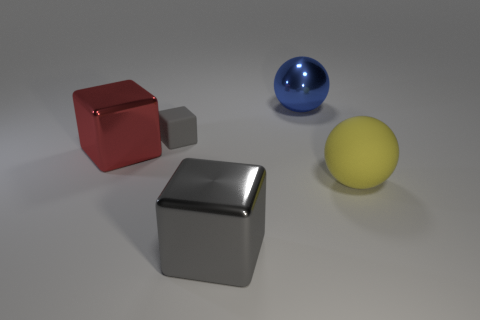Subtract all gray metallic blocks. How many blocks are left? 2 Subtract all gray balls. How many gray cubes are left? 2 Subtract 1 cubes. How many cubes are left? 2 Add 5 tiny gray rubber cubes. How many objects exist? 10 Subtract all balls. How many objects are left? 3 Subtract all cyan cubes. Subtract all red spheres. How many cubes are left? 3 Add 5 blue spheres. How many blue spheres exist? 6 Subtract 0 brown cubes. How many objects are left? 5 Subtract all large red metallic blocks. Subtract all blue objects. How many objects are left? 3 Add 4 big blue objects. How many big blue objects are left? 5 